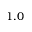Convert formula to latex. <formula><loc_0><loc_0><loc_500><loc_500>1 . 0</formula> 